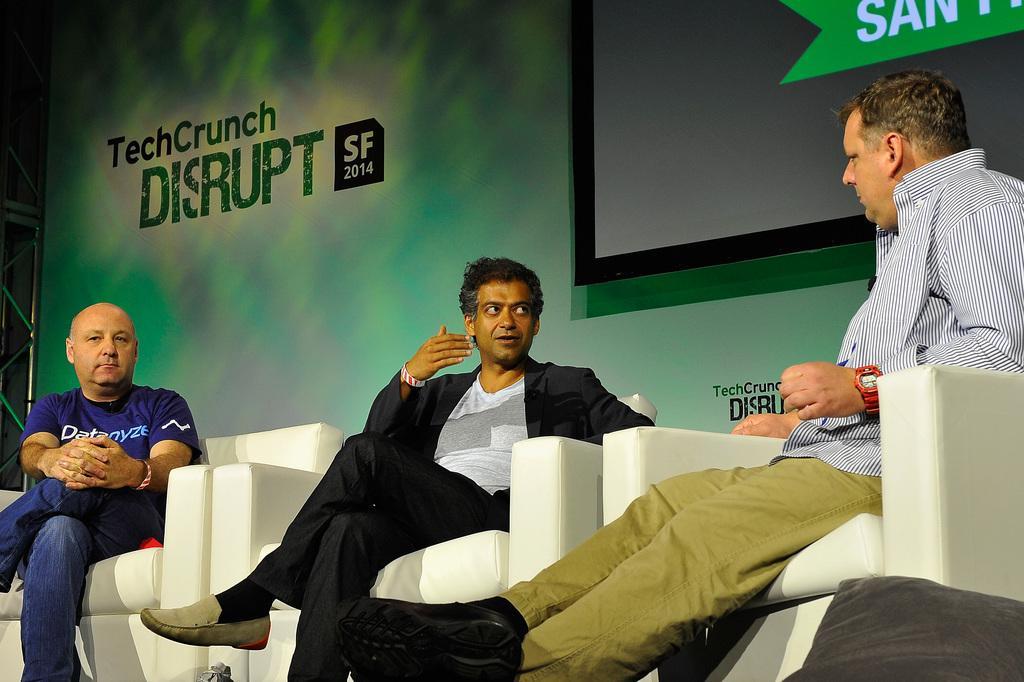Can you describe this image briefly? In this image we can see three men sitting on the chairs. We can also see a metal frame, a banner with some text on it and a display screen. 